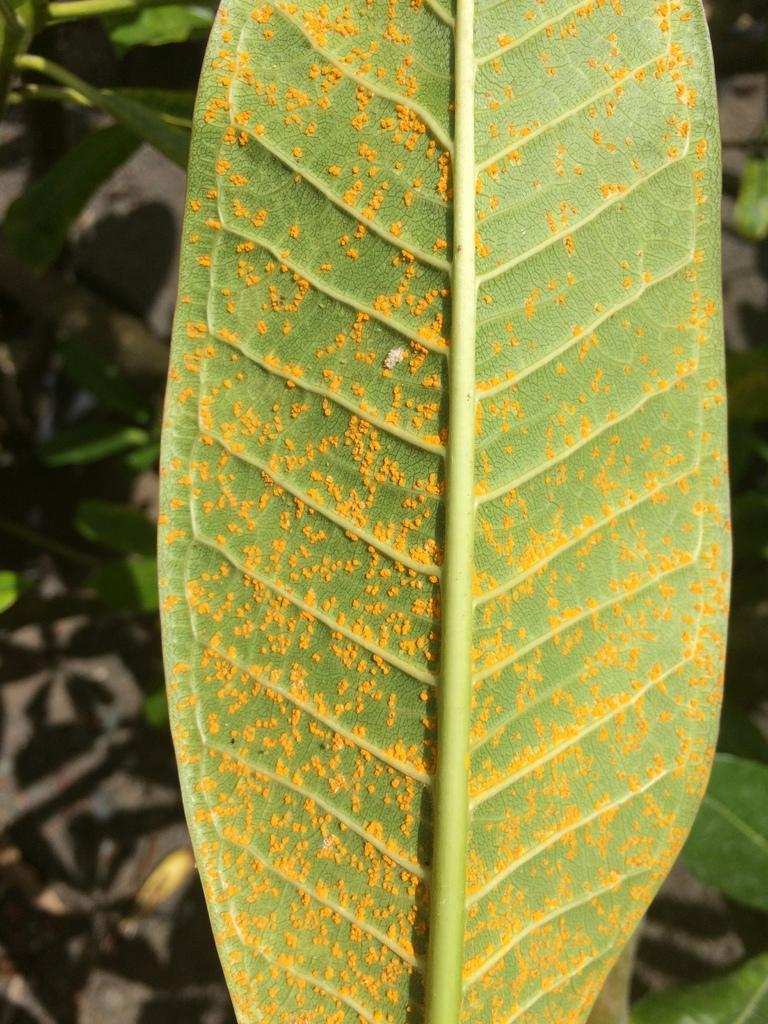What is present on the leaf in the image? There are insect eggs on the backside of the leaf in the image. What else can be seen in the image besides the leaf with insect eggs? There are other leaves visible in the image. What is the surface beneath the leaves in the image? The ground is visible in the image. Reasoning: Let's think step by step by step in order to produce the conversation. We start by identifying the main subject in the image, which is the leaf with insect eggs. Then, we expand the conversation to include other leaves visible in the image and the ground beneath them. Each question is designed to elicit a specific detail about the image that is known from the provided facts. Absurd Question/Answer: What type of brass ornament is hanging from the leaf in the image? There is no brass ornament present in the image; it only features a leaf with insect eggs and other leaves. What type of brass ornament is hanging from the leaf in the image? There is no brass ornament present in the image; it only features a leaf with insect eggs and other leaves. 